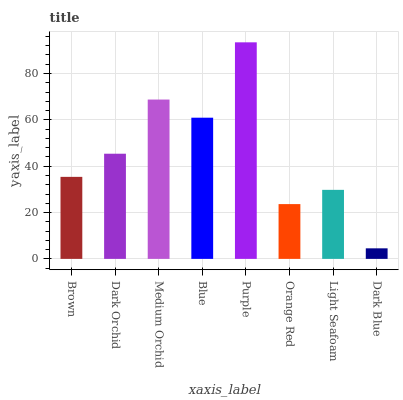Is Dark Blue the minimum?
Answer yes or no. Yes. Is Purple the maximum?
Answer yes or no. Yes. Is Dark Orchid the minimum?
Answer yes or no. No. Is Dark Orchid the maximum?
Answer yes or no. No. Is Dark Orchid greater than Brown?
Answer yes or no. Yes. Is Brown less than Dark Orchid?
Answer yes or no. Yes. Is Brown greater than Dark Orchid?
Answer yes or no. No. Is Dark Orchid less than Brown?
Answer yes or no. No. Is Dark Orchid the high median?
Answer yes or no. Yes. Is Brown the low median?
Answer yes or no. Yes. Is Light Seafoam the high median?
Answer yes or no. No. Is Dark Blue the low median?
Answer yes or no. No. 